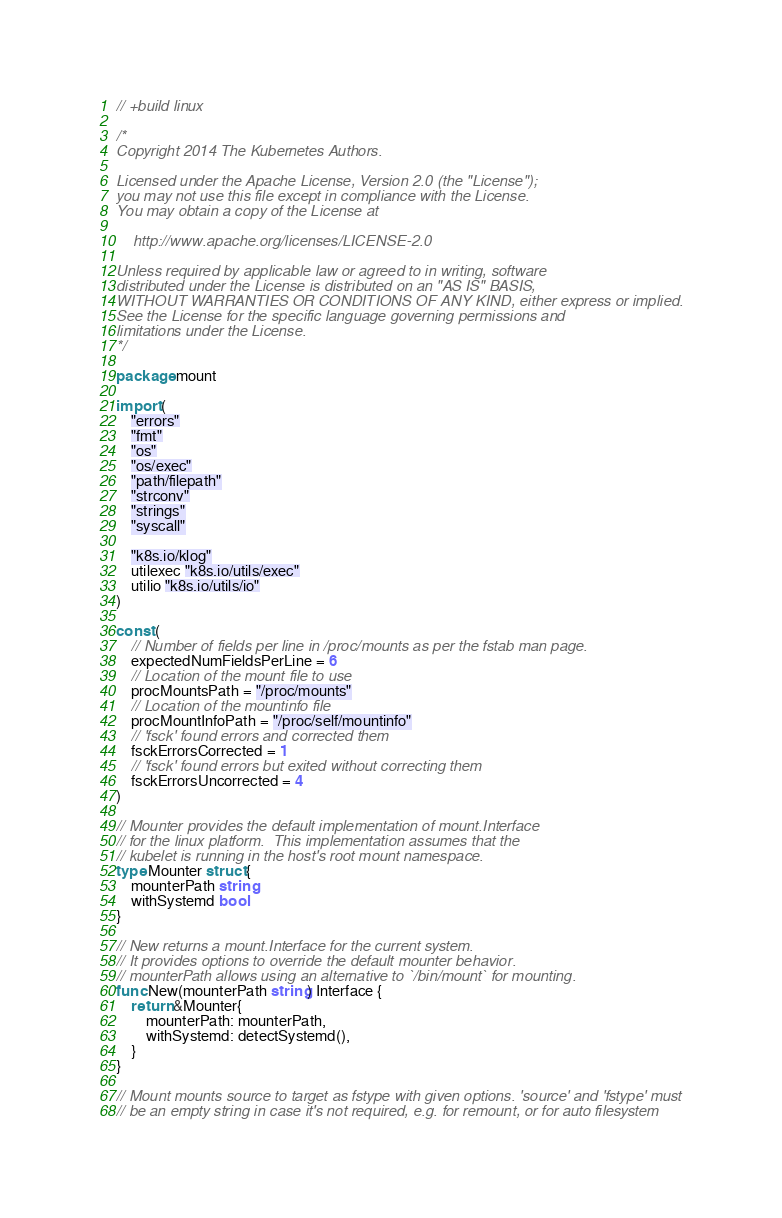Convert code to text. <code><loc_0><loc_0><loc_500><loc_500><_Go_>// +build linux

/*
Copyright 2014 The Kubernetes Authors.

Licensed under the Apache License, Version 2.0 (the "License");
you may not use this file except in compliance with the License.
You may obtain a copy of the License at

    http://www.apache.org/licenses/LICENSE-2.0

Unless required by applicable law or agreed to in writing, software
distributed under the License is distributed on an "AS IS" BASIS,
WITHOUT WARRANTIES OR CONDITIONS OF ANY KIND, either express or implied.
See the License for the specific language governing permissions and
limitations under the License.
*/

package mount

import (
	"errors"
	"fmt"
	"os"
	"os/exec"
	"path/filepath"
	"strconv"
	"strings"
	"syscall"

	"k8s.io/klog"
	utilexec "k8s.io/utils/exec"
	utilio "k8s.io/utils/io"
)

const (
	// Number of fields per line in /proc/mounts as per the fstab man page.
	expectedNumFieldsPerLine = 6
	// Location of the mount file to use
	procMountsPath = "/proc/mounts"
	// Location of the mountinfo file
	procMountInfoPath = "/proc/self/mountinfo"
	// 'fsck' found errors and corrected them
	fsckErrorsCorrected = 1
	// 'fsck' found errors but exited without correcting them
	fsckErrorsUncorrected = 4
)

// Mounter provides the default implementation of mount.Interface
// for the linux platform.  This implementation assumes that the
// kubelet is running in the host's root mount namespace.
type Mounter struct {
	mounterPath string
	withSystemd bool
}

// New returns a mount.Interface for the current system.
// It provides options to override the default mounter behavior.
// mounterPath allows using an alternative to `/bin/mount` for mounting.
func New(mounterPath string) Interface {
	return &Mounter{
		mounterPath: mounterPath,
		withSystemd: detectSystemd(),
	}
}

// Mount mounts source to target as fstype with given options. 'source' and 'fstype' must
// be an empty string in case it's not required, e.g. for remount, or for auto filesystem</code> 